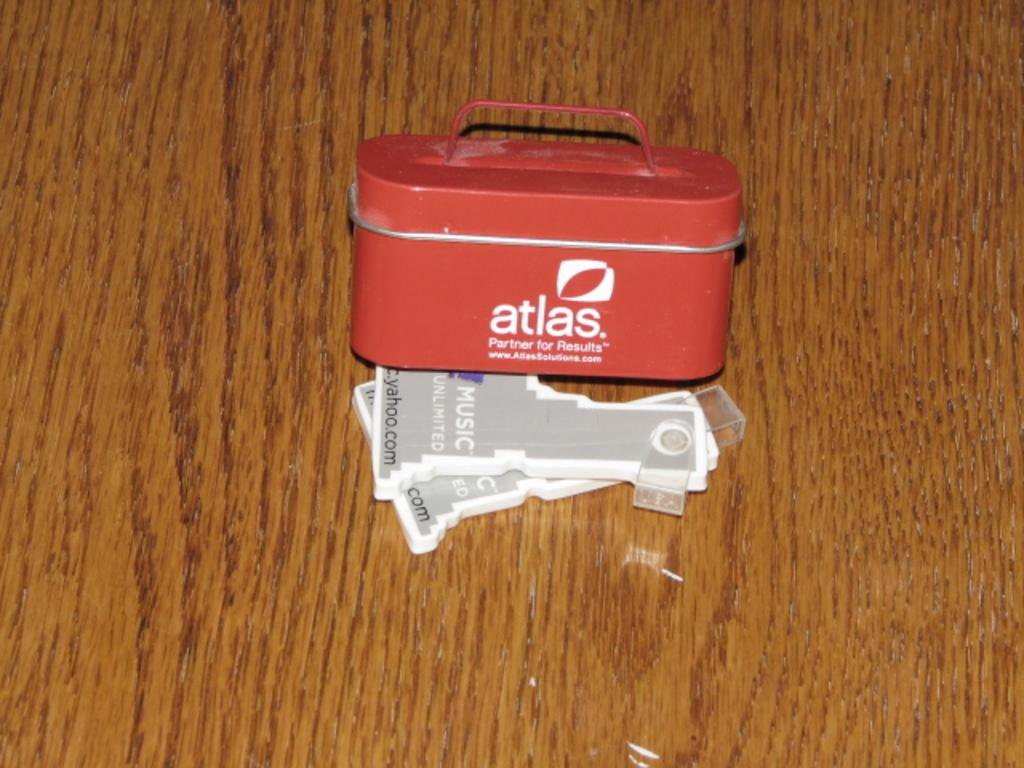<image>
Share a concise interpretation of the image provided. a small red tin that says 'atlas' in red on it 